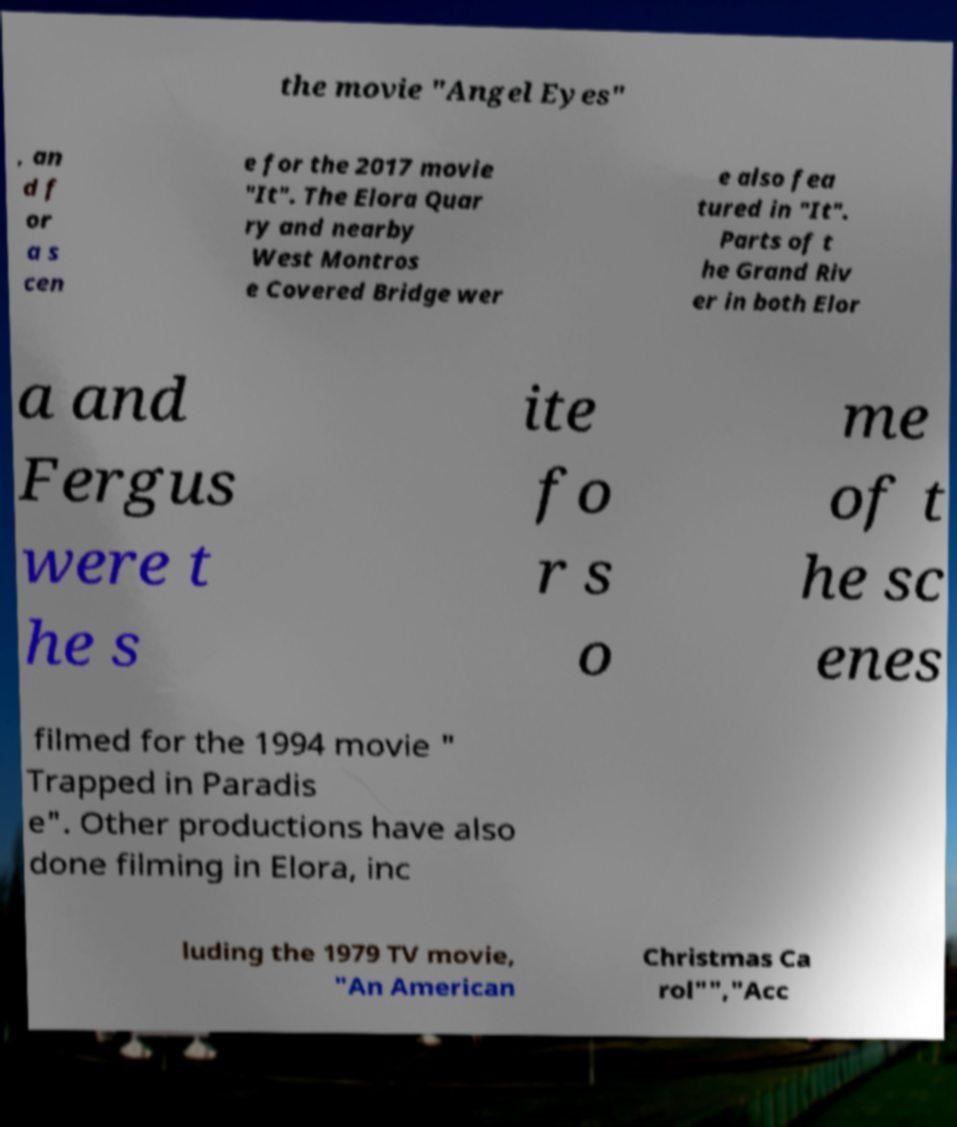Please read and relay the text visible in this image. What does it say? the movie "Angel Eyes" , an d f or a s cen e for the 2017 movie "It". The Elora Quar ry and nearby West Montros e Covered Bridge wer e also fea tured in "It". Parts of t he Grand Riv er in both Elor a and Fergus were t he s ite fo r s o me of t he sc enes filmed for the 1994 movie " Trapped in Paradis e". Other productions have also done filming in Elora, inc luding the 1979 TV movie, "An American Christmas Ca rol"","Acc 